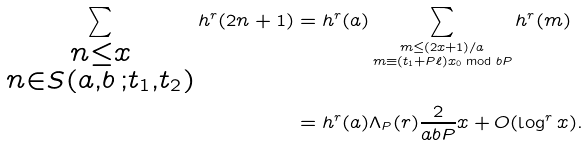<formula> <loc_0><loc_0><loc_500><loc_500>\sum _ { \substack { n \leq x \\ n \in S ( a , b \, ; t _ { 1 } , t _ { 2 } ) } } h ^ { r } ( 2 n + 1 ) & = h ^ { r } ( a ) \sum _ { \substack { m \leq ( 2 x + 1 ) / a \\ m \equiv ( t _ { 1 } + P \ell ) x _ { 0 } \bmod b P } } h ^ { r } ( m ) \\ & = h ^ { r } ( a ) \Lambda _ { P } ( r ) \frac { 2 } { a b P } x + O ( \log ^ { r } x ) .</formula> 